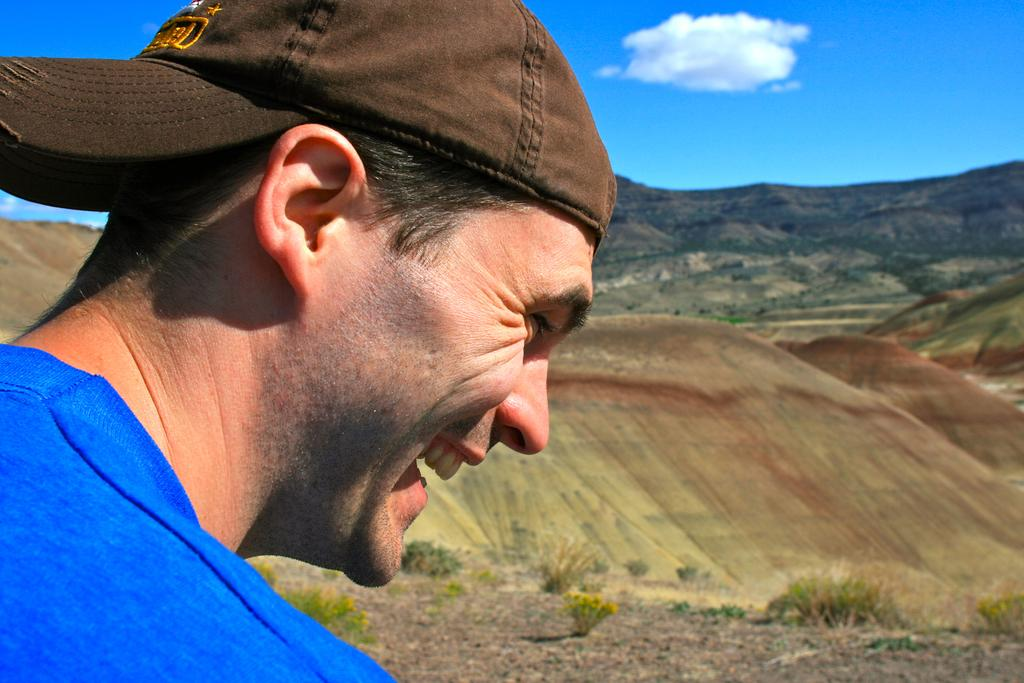Who is present in the image? There is a person in the image. What is the person wearing on their head? The person is wearing a cap. What is the person's facial expression? The person is smiling. What type of natural environment can be seen in the image? There is greenery visible in the image. What is visible in the sky? There are clouds in the sky. What group of people is attacking the person in the image? There is no group of people attacking the person in the image; the person is smiling and there is no indication of an attack. 